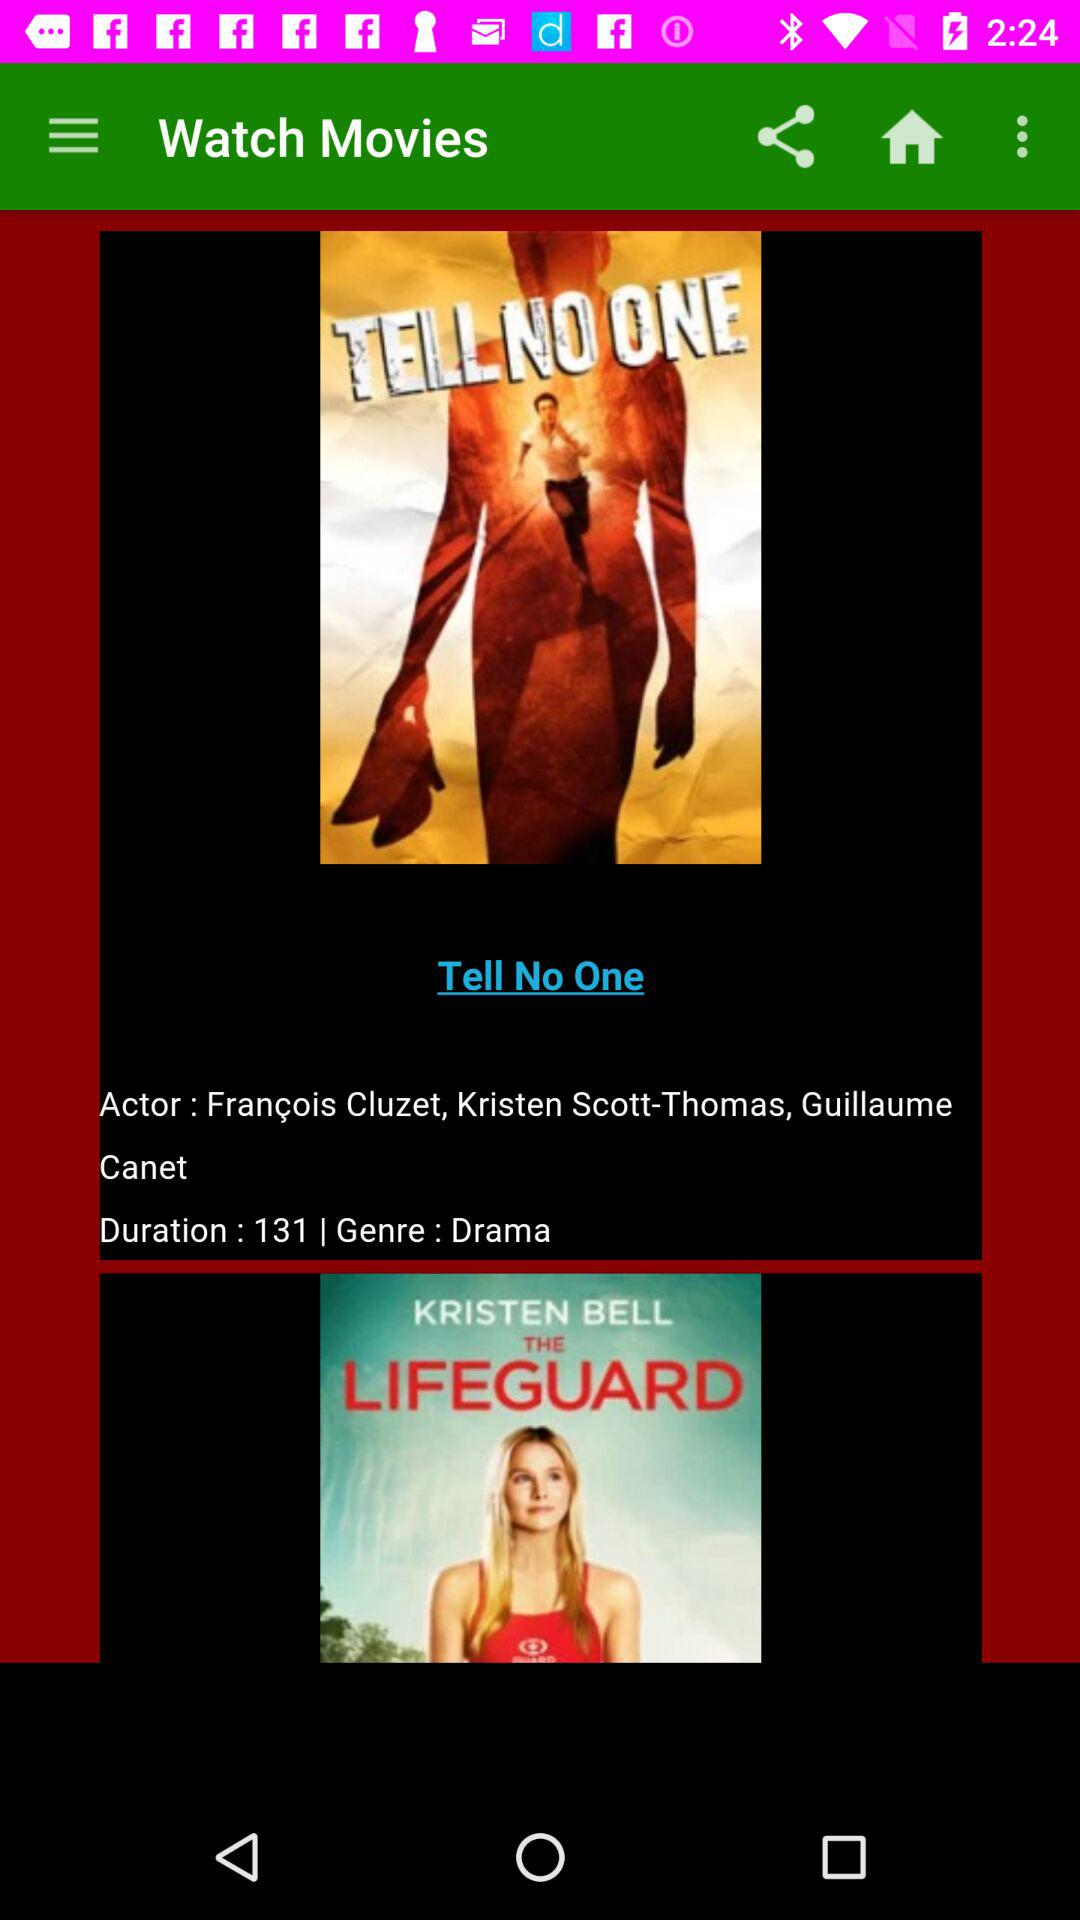What is the duration? The duration is 131. 